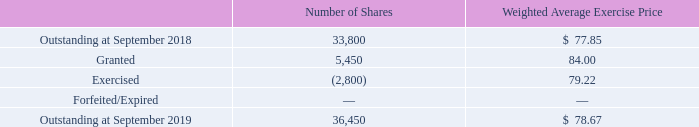The following is a summary of stock option activity during fiscal 2019:
Net income before income taxes included compensation expense related to the amortization of the Company’s stock option awards of $0.1 million during both fiscal 2019 and fiscal 2018. At September 2019, total unamortized compensation expense related to stock options was approximately $0.3 million. This unamortized compensation expense is expected to be amortized over approximately the next 38 months.
The aggregate intrinsic value of stock options exercisable was approximately $0.2 million and $0.3 million at September 2019 and September 2018, respectively.
The total intrinsic value of stock options exercised was $0.1 million in both fiscal 2019 and fiscal 2018. The total fair value of stock options vested was $0.4 million during both fiscal 2019 and fiscal 2018.
What is the compensation expense related to the amortization of the Company’s stock option awards included in the net income before income taxes in both fiscal 2018 and 2019 respectively? $0.1 million, $0.1 million. What are the aggregate intrinsic value of stock options exercisable at September 2018 and 2019 respectively? $0.3 million, $0.2 million. What is the respective total intrinsic value of stock options exercised in 2018 and 2019? $0.1 million, $0.1 million. What is the percentage change in the company's shares outstanding at September 2018 and 2019?
Answer scale should be: percent. (36,450 - 33,800)/33,800 
Answer: 7.84. What is the percentage of shares granted as a percentage of the number of outstanding shares at 2018?
Answer scale should be: percent. 5,450/33,800 
Answer: 16.12. What is the difference in the total number of shares outstanding between 2018 and 2019? 36,450-33,800 
Answer: 2650. 